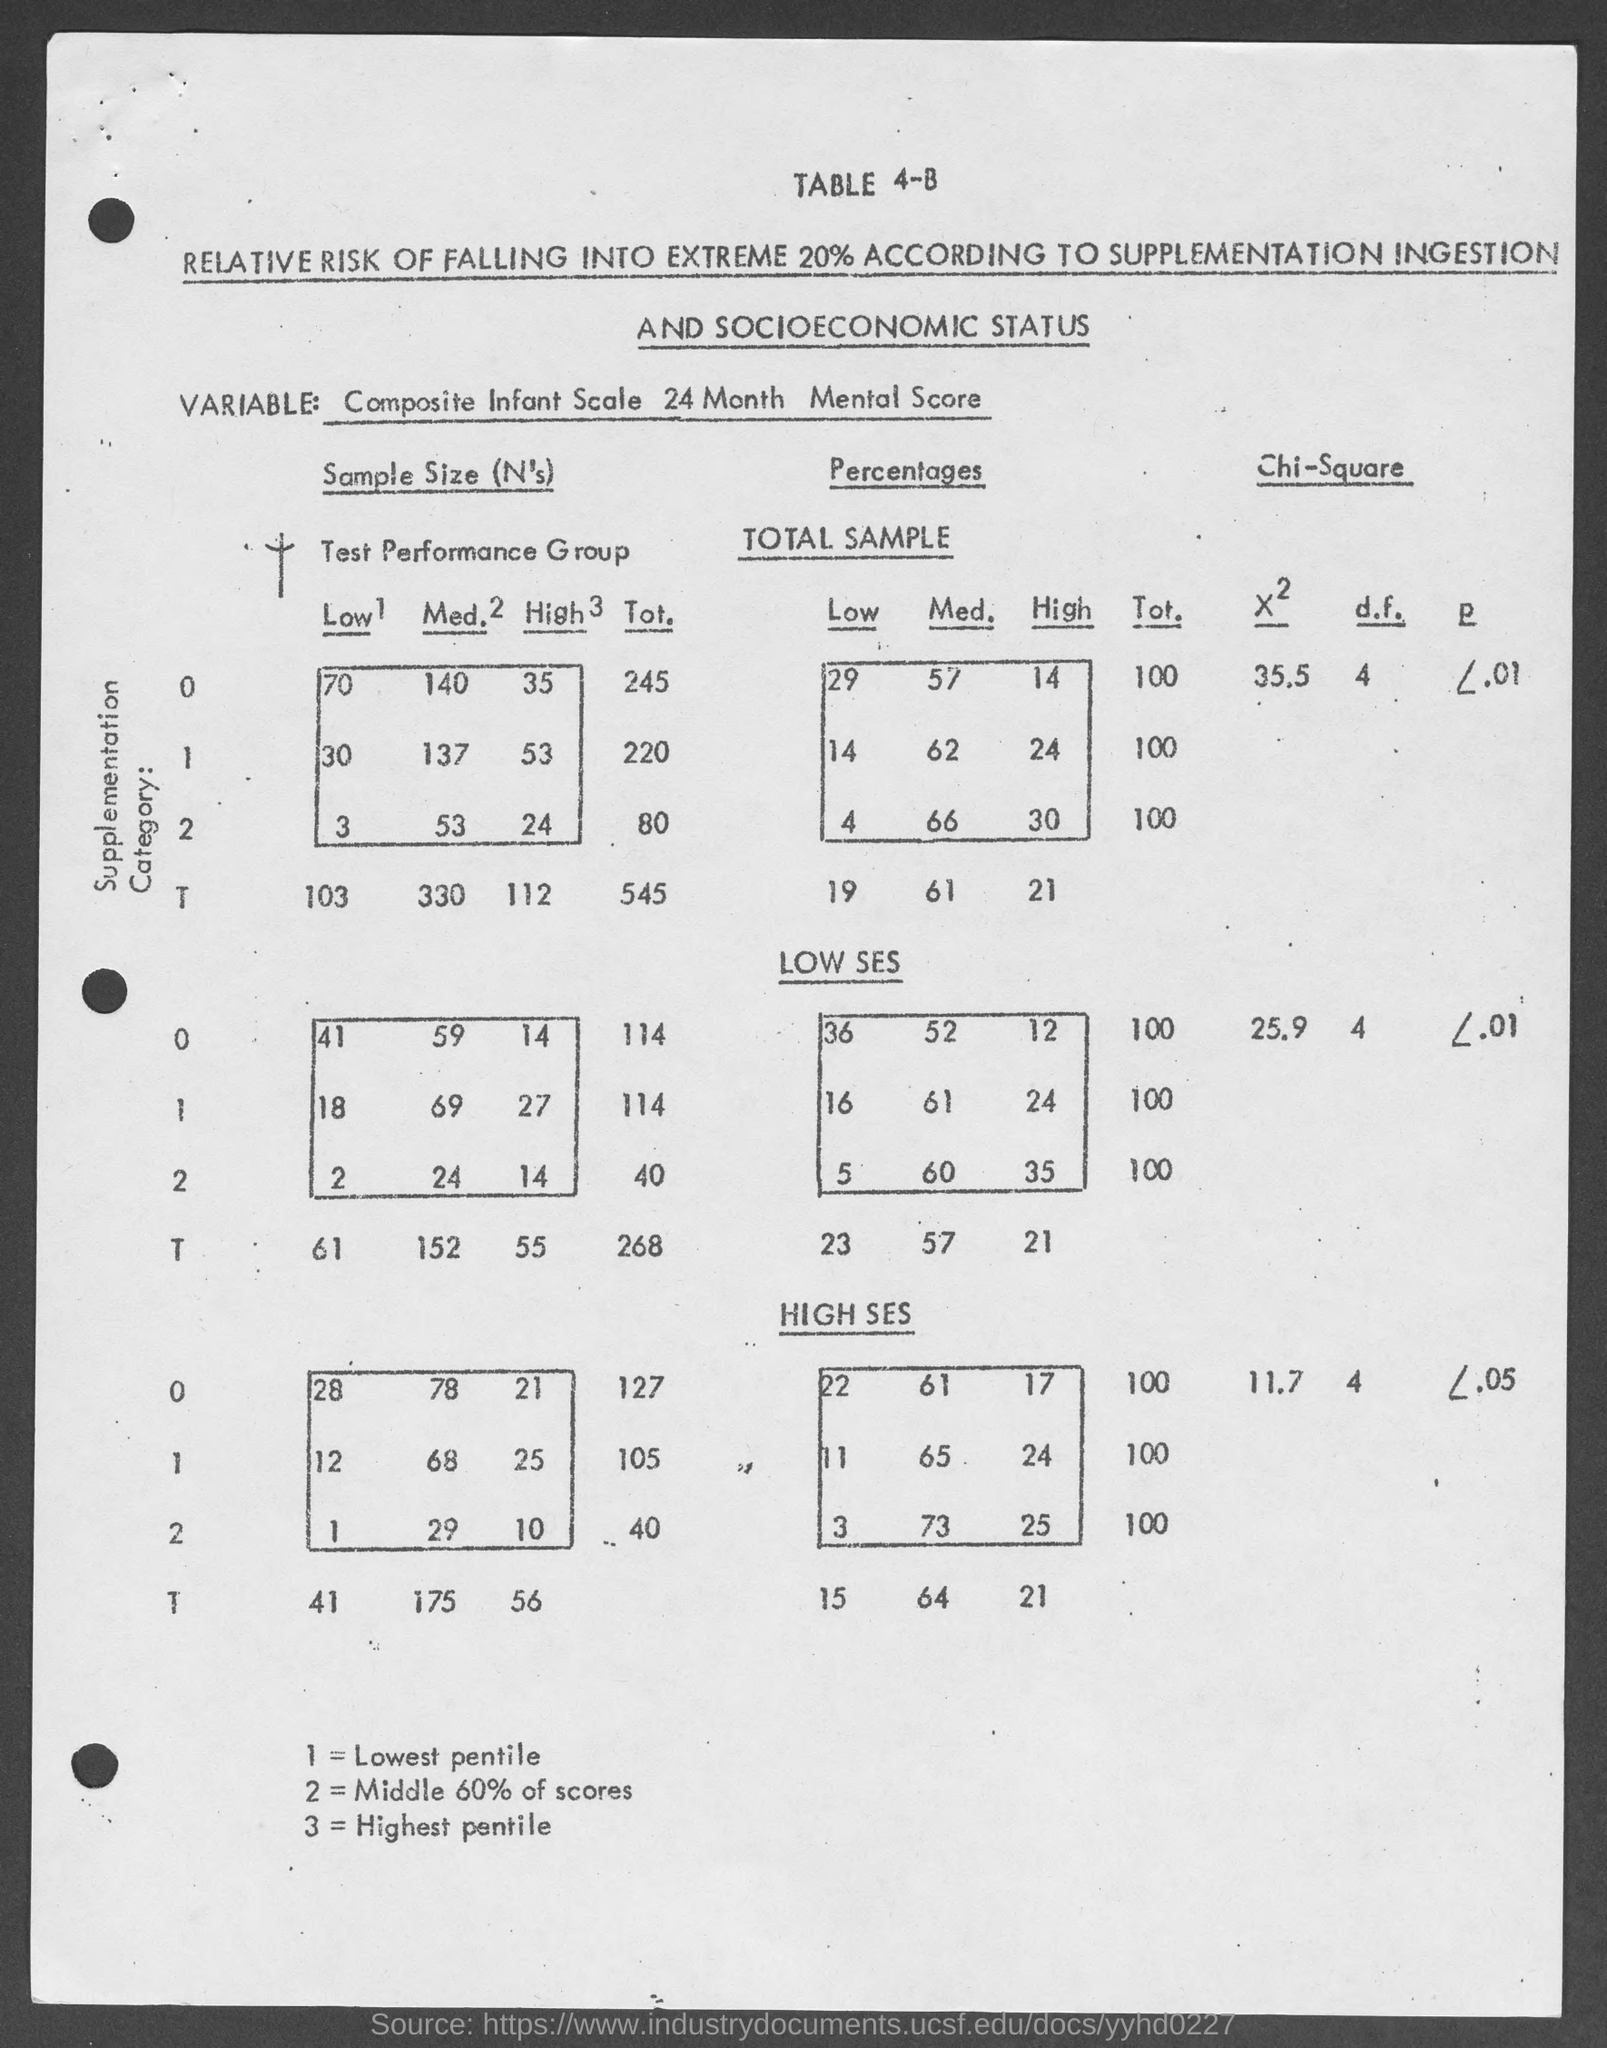What is 1= ?
Provide a short and direct response. Lowest pentile. What is 2=?
Keep it short and to the point. Middle 60% of scores. What is 3=?
Keep it short and to the point. Highest pentile. 